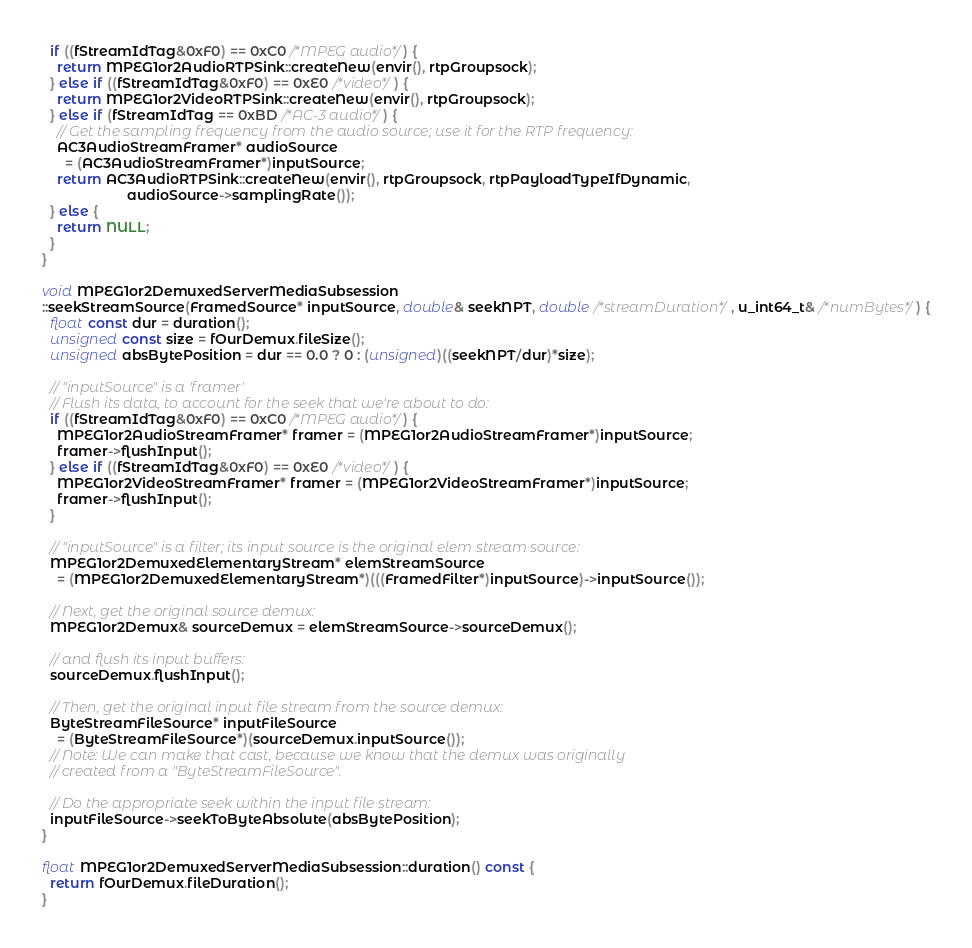<code> <loc_0><loc_0><loc_500><loc_500><_C++_>  if ((fStreamIdTag&0xF0) == 0xC0 /*MPEG audio*/) {
    return MPEG1or2AudioRTPSink::createNew(envir(), rtpGroupsock);
  } else if ((fStreamIdTag&0xF0) == 0xE0 /*video*/) {
    return MPEG1or2VideoRTPSink::createNew(envir(), rtpGroupsock);
  } else if (fStreamIdTag == 0xBD /*AC-3 audio*/) {
    // Get the sampling frequency from the audio source; use it for the RTP frequency:
    AC3AudioStreamFramer* audioSource
      = (AC3AudioStreamFramer*)inputSource;
    return AC3AudioRTPSink::createNew(envir(), rtpGroupsock, rtpPayloadTypeIfDynamic,
				      audioSource->samplingRate());
  } else {
    return NULL;
  }
}

void MPEG1or2DemuxedServerMediaSubsession
::seekStreamSource(FramedSource* inputSource, double& seekNPT, double /*streamDuration*/, u_int64_t& /*numBytes*/) {
  float const dur = duration();
  unsigned const size = fOurDemux.fileSize();
  unsigned absBytePosition = dur == 0.0 ? 0 : (unsigned)((seekNPT/dur)*size);

  // "inputSource" is a 'framer'
  // Flush its data, to account for the seek that we're about to do:
  if ((fStreamIdTag&0xF0) == 0xC0 /*MPEG audio*/) {
    MPEG1or2AudioStreamFramer* framer = (MPEG1or2AudioStreamFramer*)inputSource;
    framer->flushInput();
  } else if ((fStreamIdTag&0xF0) == 0xE0 /*video*/) {
    MPEG1or2VideoStreamFramer* framer = (MPEG1or2VideoStreamFramer*)inputSource;
    framer->flushInput();
  }

  // "inputSource" is a filter; its input source is the original elem stream source:
  MPEG1or2DemuxedElementaryStream* elemStreamSource
    = (MPEG1or2DemuxedElementaryStream*)(((FramedFilter*)inputSource)->inputSource());

  // Next, get the original source demux:
  MPEG1or2Demux& sourceDemux = elemStreamSource->sourceDemux();

  // and flush its input buffers:
  sourceDemux.flushInput();

  // Then, get the original input file stream from the source demux:
  ByteStreamFileSource* inputFileSource
    = (ByteStreamFileSource*)(sourceDemux.inputSource());
  // Note: We can make that cast, because we know that the demux was originally
  // created from a "ByteStreamFileSource".

  // Do the appropriate seek within the input file stream:
  inputFileSource->seekToByteAbsolute(absBytePosition);
}

float MPEG1or2DemuxedServerMediaSubsession::duration() const {
  return fOurDemux.fileDuration();
}
</code> 